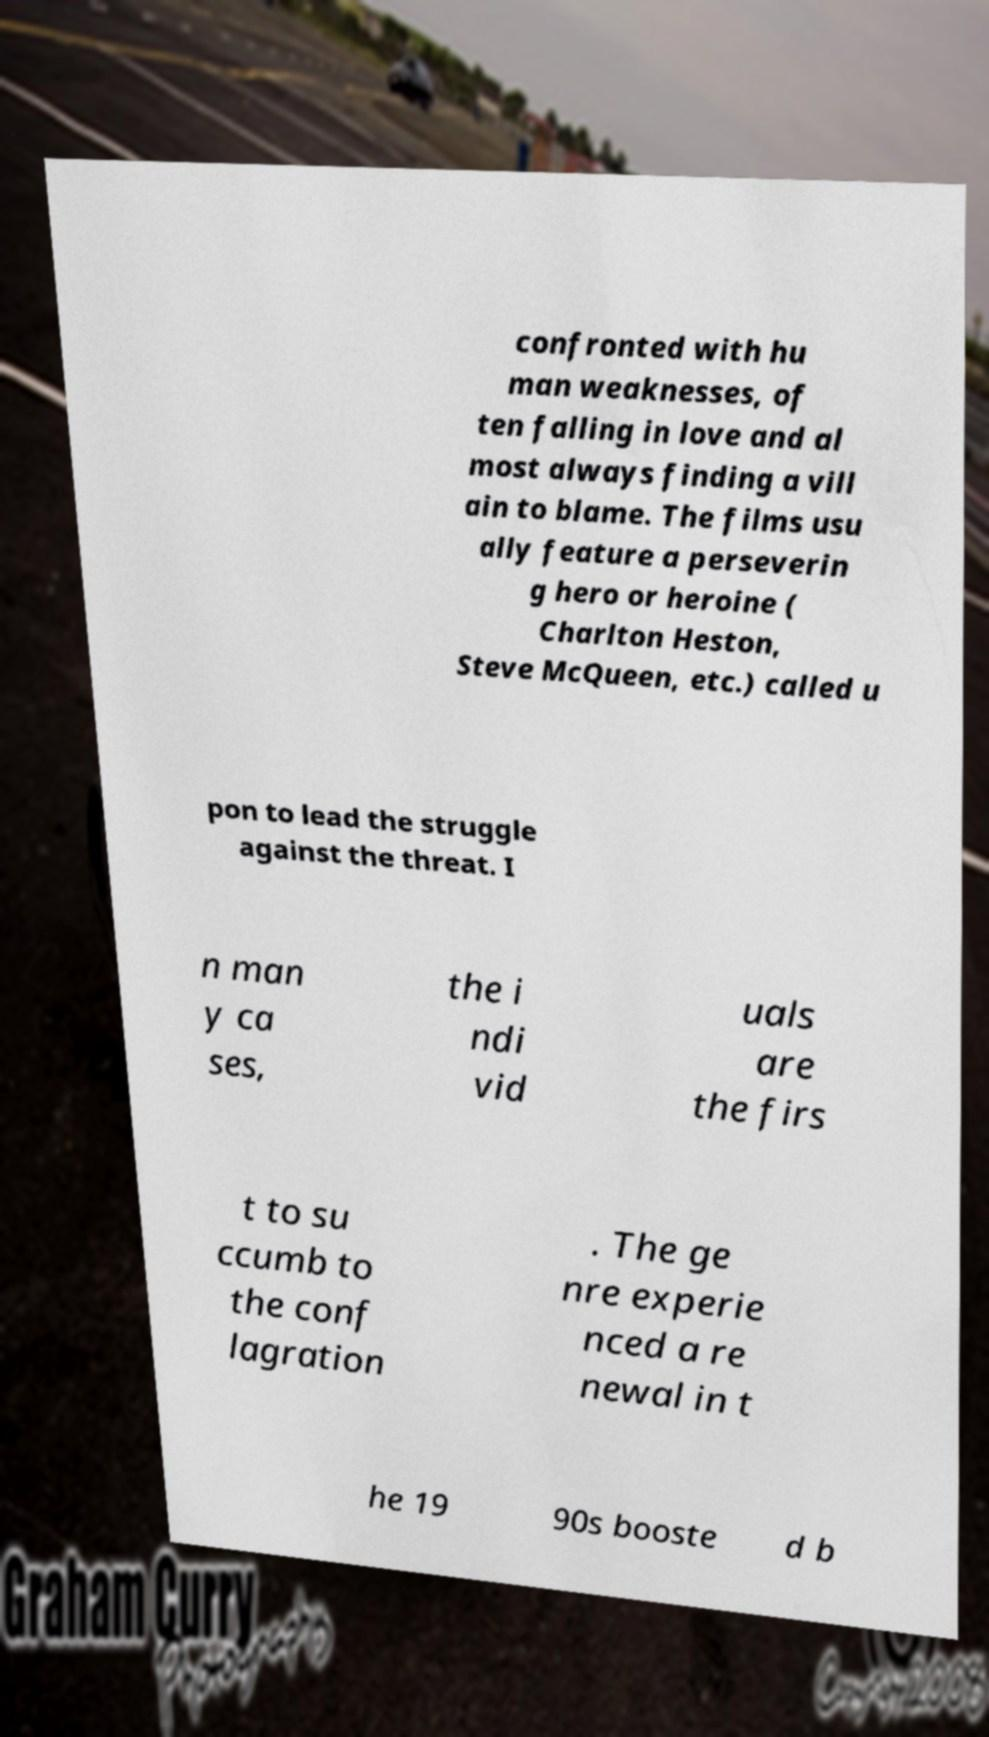I need the written content from this picture converted into text. Can you do that? confronted with hu man weaknesses, of ten falling in love and al most always finding a vill ain to blame. The films usu ally feature a perseverin g hero or heroine ( Charlton Heston, Steve McQueen, etc.) called u pon to lead the struggle against the threat. I n man y ca ses, the i ndi vid uals are the firs t to su ccumb to the conf lagration . The ge nre experie nced a re newal in t he 19 90s booste d b 